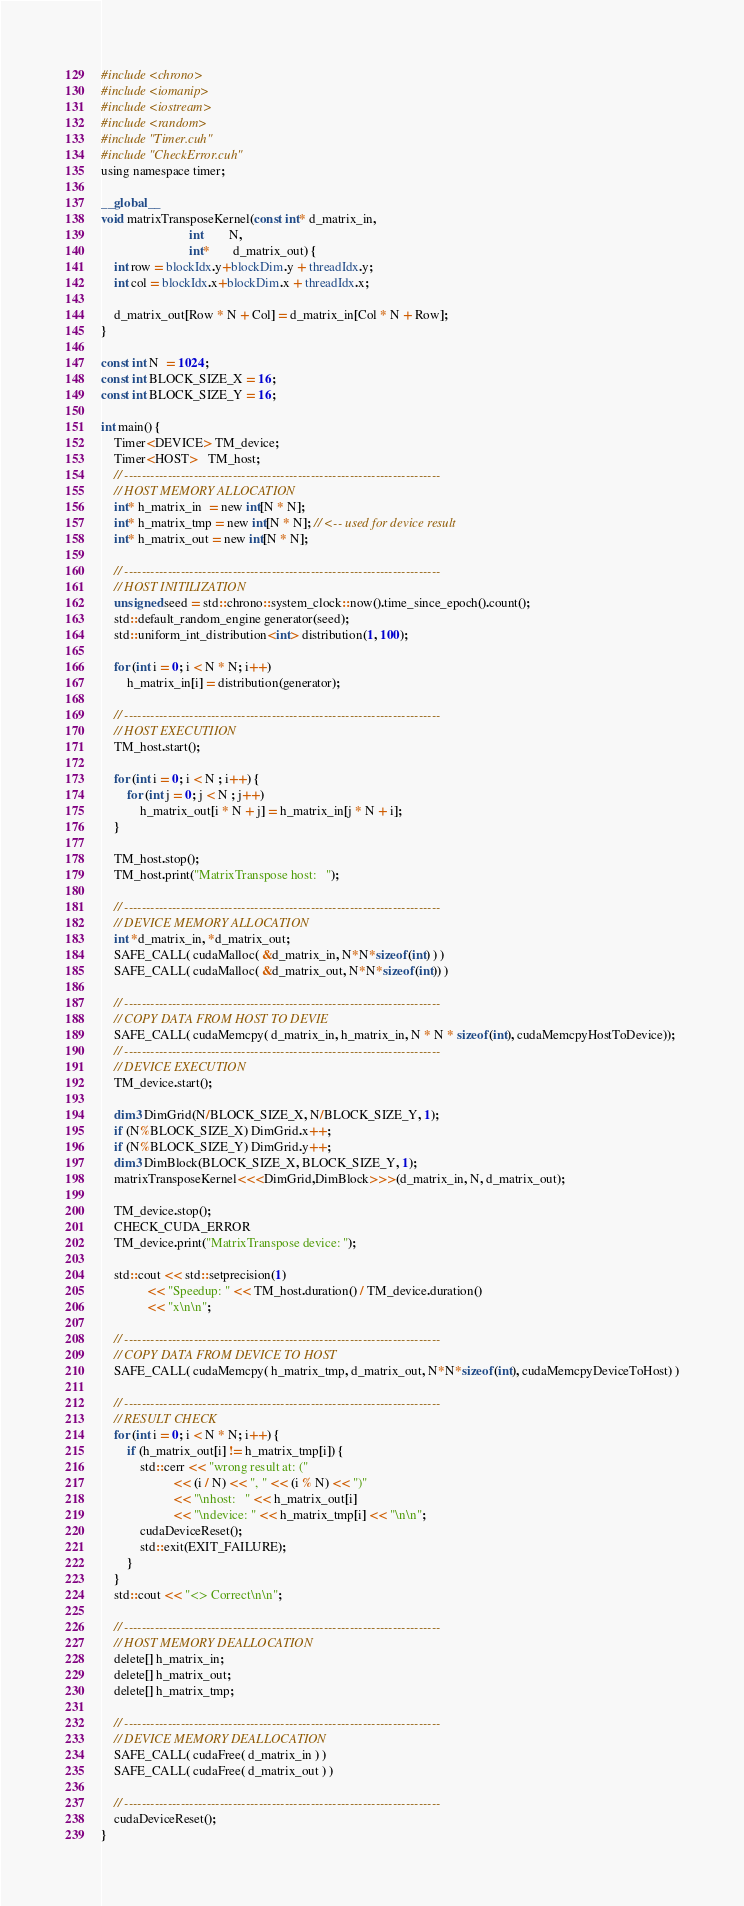<code> <loc_0><loc_0><loc_500><loc_500><_Cuda_>#include <chrono>
#include <iomanip>
#include <iostream>
#include <random>
#include "Timer.cuh"
#include "CheckError.cuh"
using namespace timer;

__global__
void matrixTransposeKernel(const int* d_matrix_in,
                           int        N,
                           int*       d_matrix_out) {
    int row = blockIdx.y+blockDim.y + threadIdx.y;
    int col = blockIdx.x+blockDim.x + threadIdx.x;

    d_matrix_out[Row * N + Col] = d_matrix_in[Col * N + Row];
}

const int N  = 1024;
const int BLOCK_SIZE_X = 16;
const int BLOCK_SIZE_Y = 16;

int main() {
    Timer<DEVICE> TM_device;
    Timer<HOST>   TM_host;
    // -------------------------------------------------------------------------
    // HOST MEMORY ALLOCATION
    int* h_matrix_in  = new int[N * N];
    int* h_matrix_tmp = new int[N * N]; // <-- used for device result
    int* h_matrix_out = new int[N * N];

    // -------------------------------------------------------------------------
    // HOST INITILIZATION
    unsigned seed = std::chrono::system_clock::now().time_since_epoch().count();
    std::default_random_engine generator(seed);
    std::uniform_int_distribution<int> distribution(1, 100);

    for (int i = 0; i < N * N; i++)
        h_matrix_in[i] = distribution(generator);

    // -------------------------------------------------------------------------
    // HOST EXECUTIION
    TM_host.start();

    for (int i = 0; i < N ; i++) {
        for (int j = 0; j < N ; j++)
            h_matrix_out[i * N + j] = h_matrix_in[j * N + i];
    }

    TM_host.stop();
    TM_host.print("MatrixTranspose host:   ");

    // -------------------------------------------------------------------------
    // DEVICE MEMORY ALLOCATION
    int *d_matrix_in, *d_matrix_out;
    SAFE_CALL( cudaMalloc( &d_matrix_in, N*N*sizeof(int) ) )
    SAFE_CALL( cudaMalloc( &d_matrix_out, N*N*sizeof(int)) )

    // -------------------------------------------------------------------------
    // COPY DATA FROM HOST TO DEVIE
    SAFE_CALL( cudaMemcpy( d_matrix_in, h_matrix_in, N * N * sizeof(int), cudaMemcpyHostToDevice));
    // -------------------------------------------------------------------------
    // DEVICE EXECUTION
    TM_device.start();

    dim3 DimGrid(N/BLOCK_SIZE_X, N/BLOCK_SIZE_Y, 1);
    if (N%BLOCK_SIZE_X) DimGrid.x++;
    if (N%BLOCK_SIZE_Y) DimGrid.y++;
    dim3 DimBlock(BLOCK_SIZE_X, BLOCK_SIZE_Y, 1);
    matrixTransposeKernel<<<DimGrid,DimBlock>>>(d_matrix_in, N, d_matrix_out);

    TM_device.stop();
    CHECK_CUDA_ERROR
    TM_device.print("MatrixTranspose device: ");

    std::cout << std::setprecision(1)
              << "Speedup: " << TM_host.duration() / TM_device.duration()
              << "x\n\n";

    // -------------------------------------------------------------------------
    // COPY DATA FROM DEVICE TO HOST
    SAFE_CALL( cudaMemcpy( h_matrix_tmp, d_matrix_out, N*N*sizeof(int), cudaMemcpyDeviceToHost) )

    // -------------------------------------------------------------------------
    // RESULT CHECK
    for (int i = 0; i < N * N; i++) {
        if (h_matrix_out[i] != h_matrix_tmp[i]) {
            std::cerr << "wrong result at: ("
                      << (i / N) << ", " << (i % N) << ")"
                      << "\nhost:   " << h_matrix_out[i]
                      << "\ndevice: " << h_matrix_tmp[i] << "\n\n";
            cudaDeviceReset();
            std::exit(EXIT_FAILURE);
        }
    }
    std::cout << "<> Correct\n\n";

    // -------------------------------------------------------------------------
    // HOST MEMORY DEALLOCATION
    delete[] h_matrix_in;
    delete[] h_matrix_out;
    delete[] h_matrix_tmp;

    // -------------------------------------------------------------------------
    // DEVICE MEMORY DEALLOCATION
    SAFE_CALL( cudaFree( d_matrix_in ) )
    SAFE_CALL( cudaFree( d_matrix_out ) )

    // -------------------------------------------------------------------------
    cudaDeviceReset();
}
</code> 